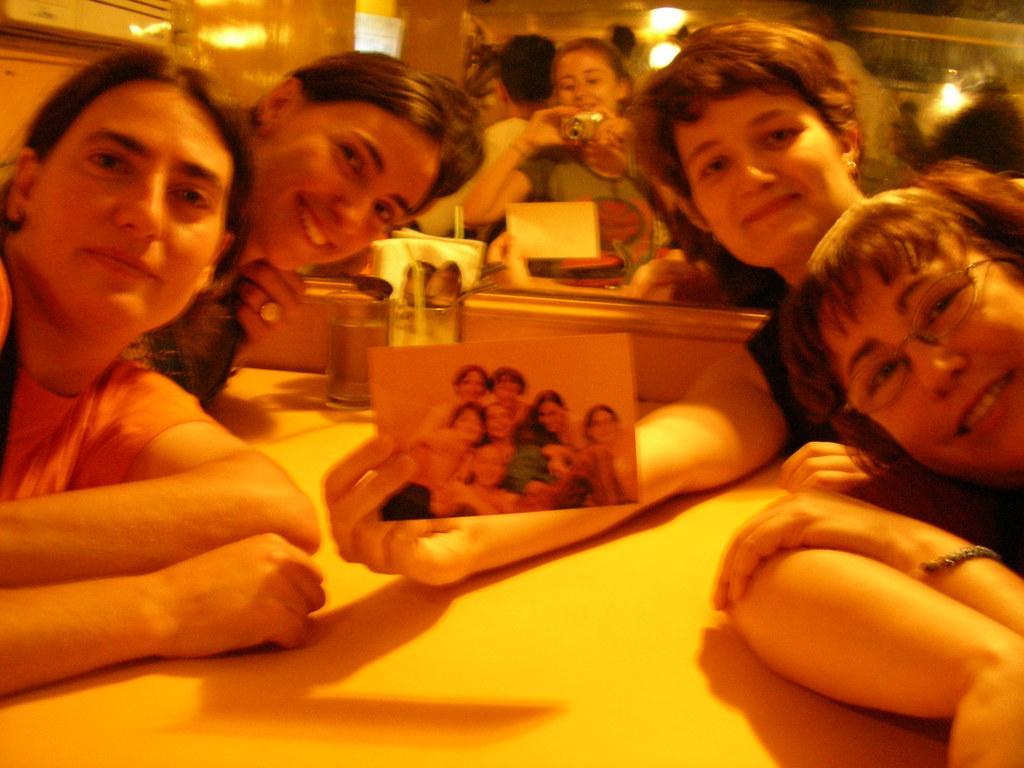Can you describe this image briefly? On the background we can see lights and few persons. Here we can see four persons giving a still to the camera. This person is holding a photo in hand. We can see this woman is holding a camera in her hands. On the table we can see glasses with straws. 